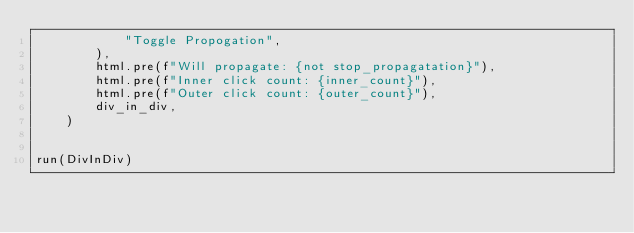<code> <loc_0><loc_0><loc_500><loc_500><_Python_>            "Toggle Propogation",
        ),
        html.pre(f"Will propagate: {not stop_propagatation}"),
        html.pre(f"Inner click count: {inner_count}"),
        html.pre(f"Outer click count: {outer_count}"),
        div_in_div,
    )


run(DivInDiv)
</code> 